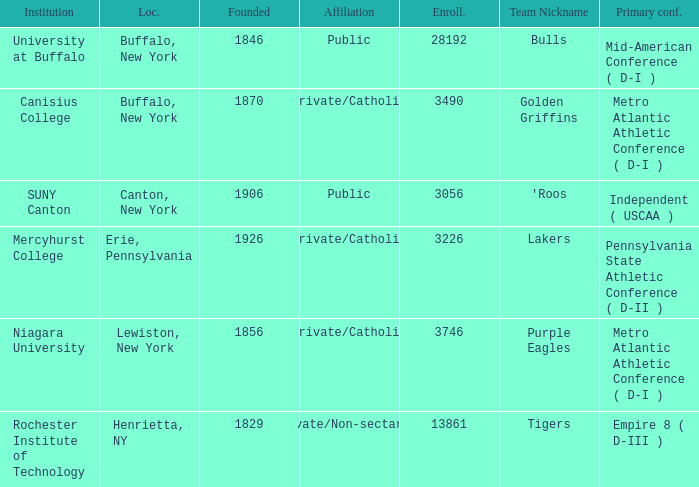What affiliation is Erie, Pennsylvania? Private/Catholic. 